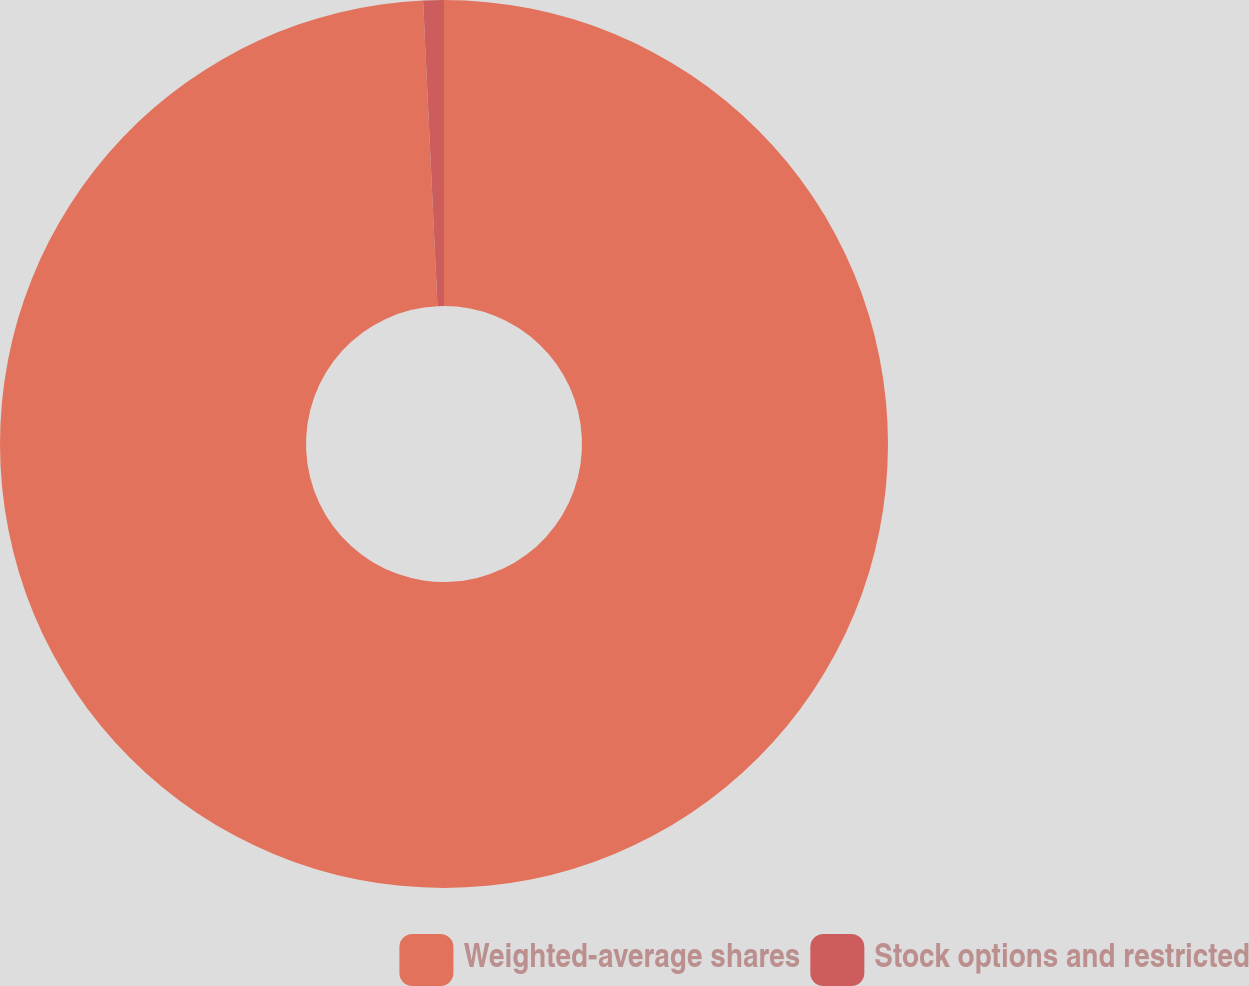<chart> <loc_0><loc_0><loc_500><loc_500><pie_chart><fcel>Weighted-average shares<fcel>Stock options and restricted<nl><fcel>99.25%<fcel>0.75%<nl></chart> 